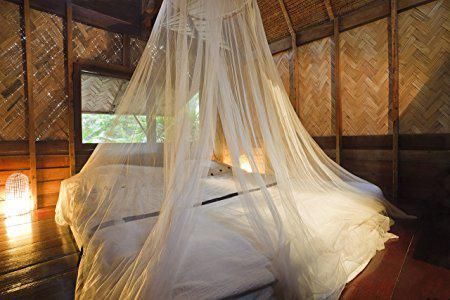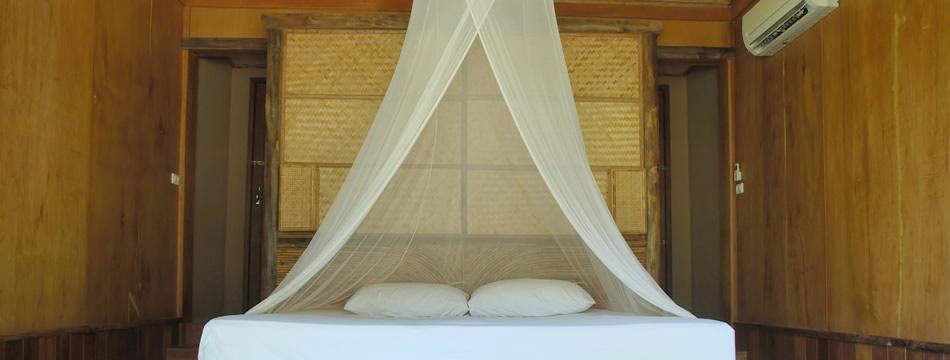The first image is the image on the left, the second image is the image on the right. For the images shown, is this caption "There are two white pillows in the image to the right." true? Answer yes or no. Yes. 